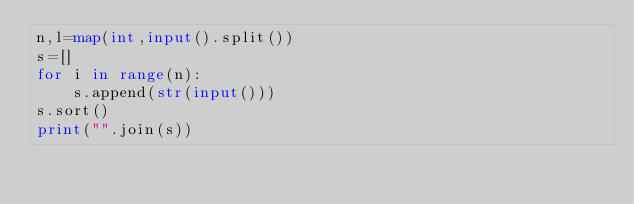<code> <loc_0><loc_0><loc_500><loc_500><_Python_>n,l=map(int,input().split())
s=[]
for i in range(n):
    s.append(str(input()))
s.sort()
print("".join(s))
</code> 